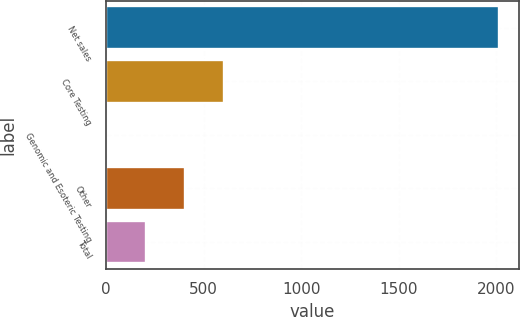Convert chart to OTSL. <chart><loc_0><loc_0><loc_500><loc_500><bar_chart><fcel>Net sales<fcel>Core Testing<fcel>Genomic and Esoteric Testing<fcel>Other<fcel>Total<nl><fcel>2014<fcel>604.41<fcel>0.3<fcel>403.04<fcel>201.67<nl></chart> 